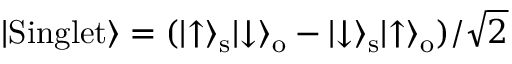<formula> <loc_0><loc_0><loc_500><loc_500>| S i n g l e t \rangle = ( | \uparrow \rangle _ { s } | \downarrow \rangle _ { o } - | \downarrow \rangle _ { s } | \uparrow \rangle _ { o } ) / \sqrt { 2 }</formula> 